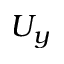Convert formula to latex. <formula><loc_0><loc_0><loc_500><loc_500>U _ { y }</formula> 